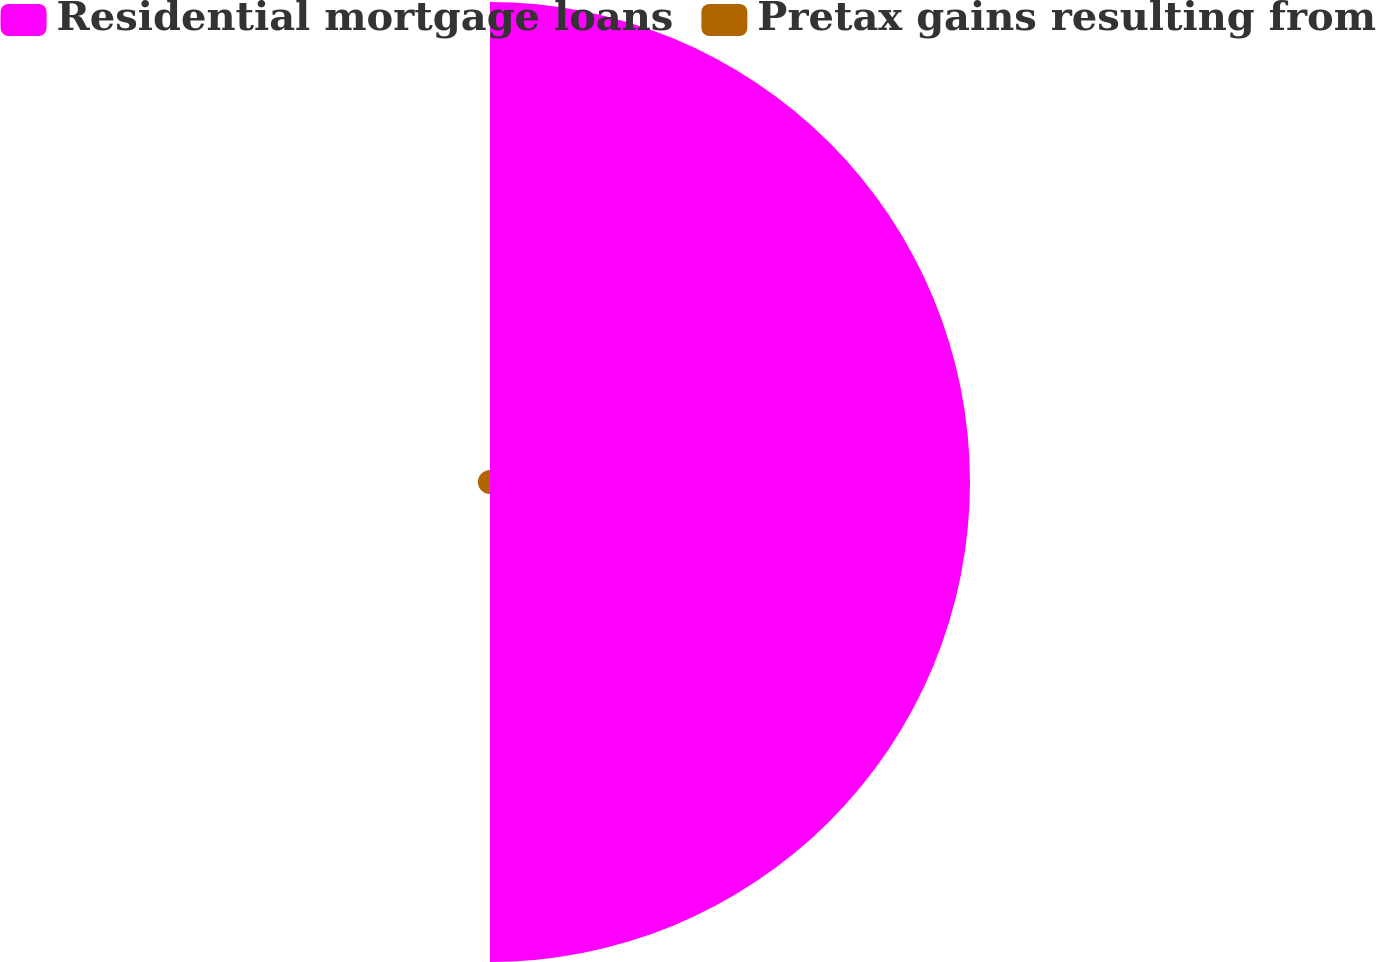Convert chart to OTSL. <chart><loc_0><loc_0><loc_500><loc_500><pie_chart><fcel>Residential mortgage loans<fcel>Pretax gains resulting from<nl><fcel>97.54%<fcel>2.46%<nl></chart> 